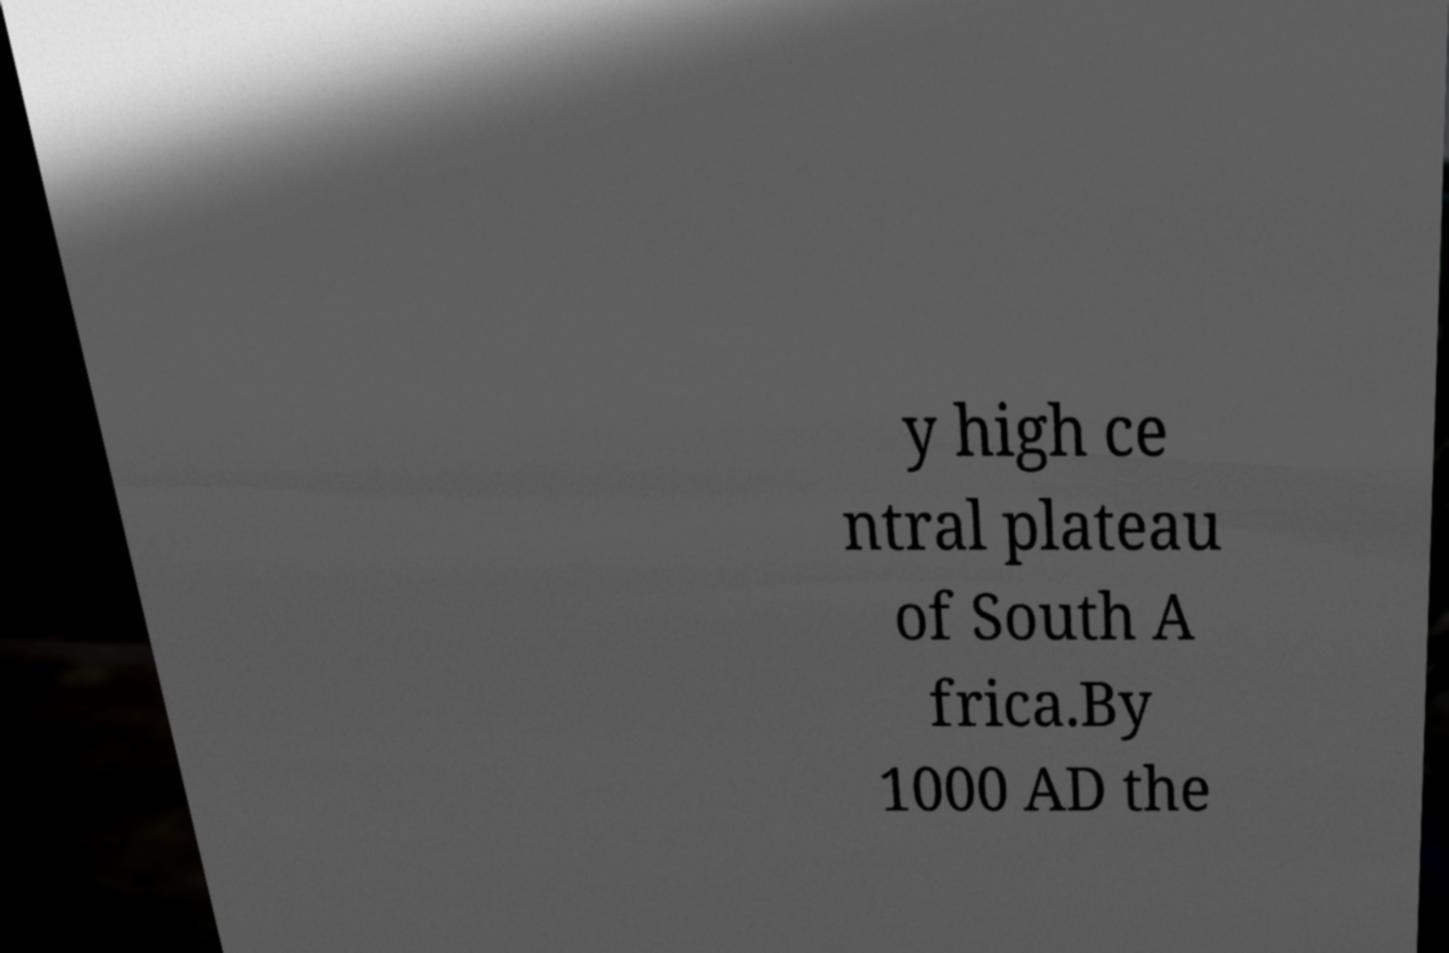Can you read and provide the text displayed in the image?This photo seems to have some interesting text. Can you extract and type it out for me? y high ce ntral plateau of South A frica.By 1000 AD the 